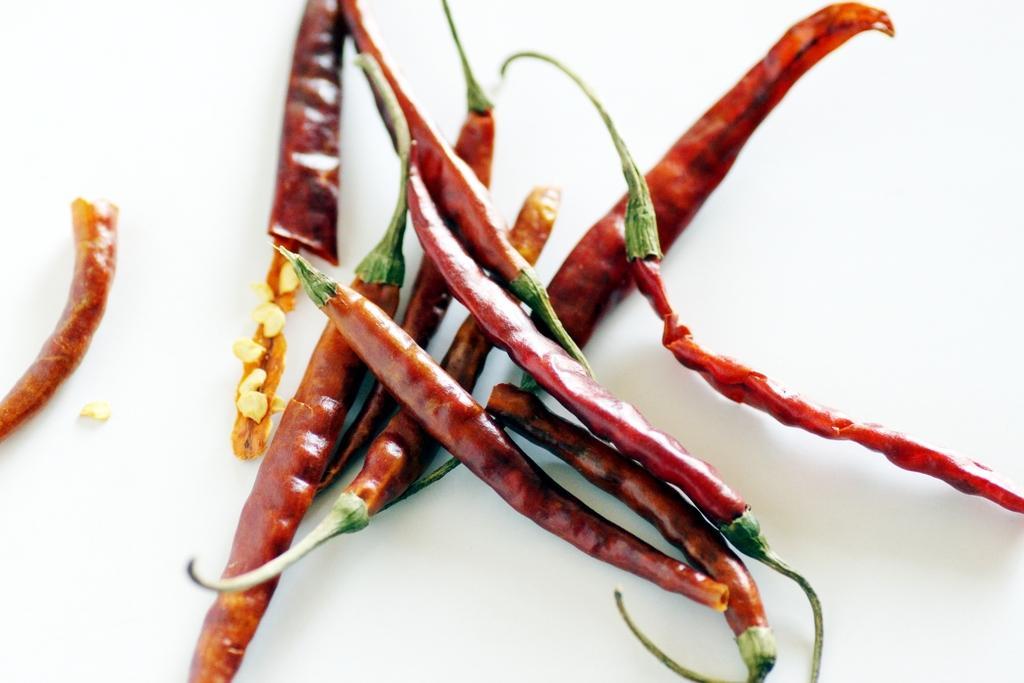Could you give a brief overview of what you see in this image? In this picture we can see few chilis. 